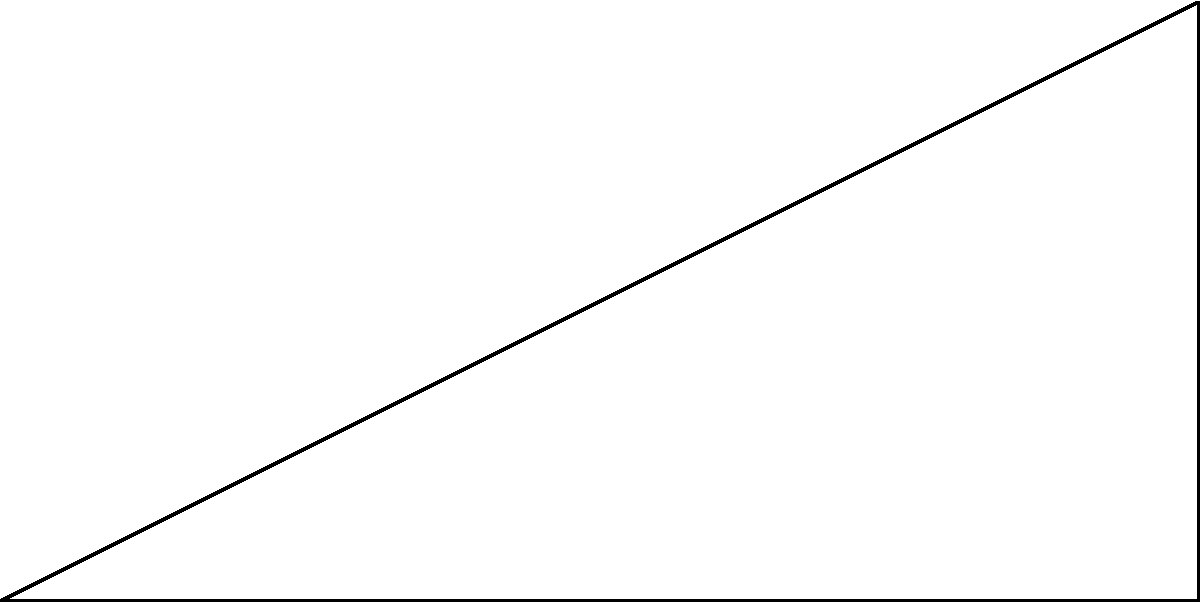At the end of a straight section of a speedway track, there's a triangular safety zone. The straight section is 60 meters long, and the safety zone extends 30 meters perpendicular to the track. If the angle between the track and the hypotenuse of the safety zone is $\theta$, what is the area of the safety zone in square meters? Let's approach this step-by-step:

1) We have a right-angled triangle. Let's call the vertices A, B, and C, where:
   A is the start of the safety zone
   B is the end of the straight section
   C is the tip of the safety zone

2) We know:
   AB = 60 m (length of straight section)
   BC = 30 m (perpendicular extension of safety zone)

3) To find the area, we need to use the formula: Area = $\frac{1}{2} \times base \times height$

4) We already know the base (AB) and height (BC), so we can directly calculate:

   Area = $\frac{1}{2} \times 60 \times 30$

5) Simplifying:
   Area = $\frac{1}{2} \times 1800 = 900$

Therefore, the area of the safety zone is 900 square meters.

Note: While we were given the angle $\theta$, it wasn't necessary for this calculation. However, if we wanted to find $\theta$, we could use the tangent function:

$\tan(\theta) = \frac{opposite}{adjacent} = \frac{30}{60} = \frac{1}{2}$

$\theta = \arctan(\frac{1}{2}) \approx 26.57°$

This angle might be useful for other safety considerations in speedway track design.
Answer: 900 m² 